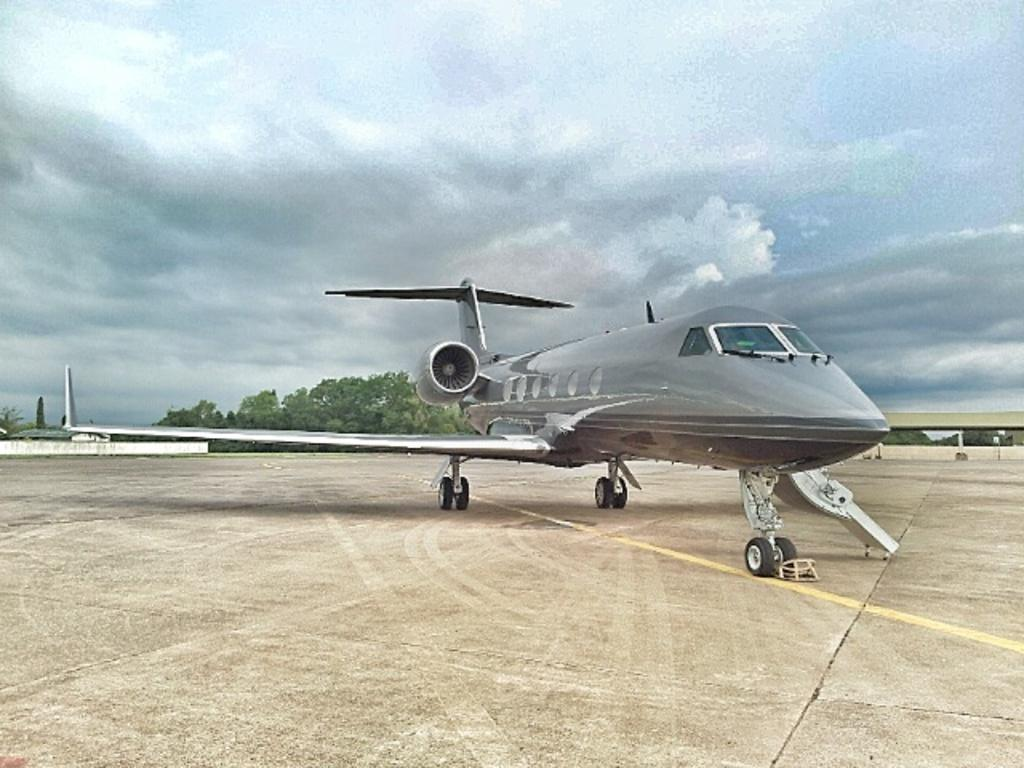What is the main subject of the image? The main subject of the image is an airplane. Where is the airplane located? The airplane is on empty land. What can be seen behind the airplane? There are many trees behind the airplane. What is visible in the background of the image? The sky is visible in the background. How many brushes are being used by the mom in the image? There is no mom or brush present in the image. What type of boats can be seen sailing in the background of the image? There are no boats visible in the image; only the airplane, trees, and sky are present. 